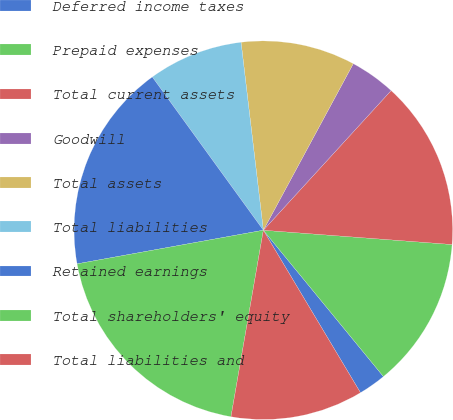Convert chart. <chart><loc_0><loc_0><loc_500><loc_500><pie_chart><fcel>Deferred income taxes<fcel>Prepaid expenses<fcel>Total current assets<fcel>Goodwill<fcel>Total assets<fcel>Total liabilities<fcel>Retained earnings<fcel>Total shareholders' equity<fcel>Total liabilities and<nl><fcel>2.36%<fcel>12.86%<fcel>14.41%<fcel>3.91%<fcel>9.76%<fcel>8.1%<fcel>17.86%<fcel>19.42%<fcel>11.31%<nl></chart> 